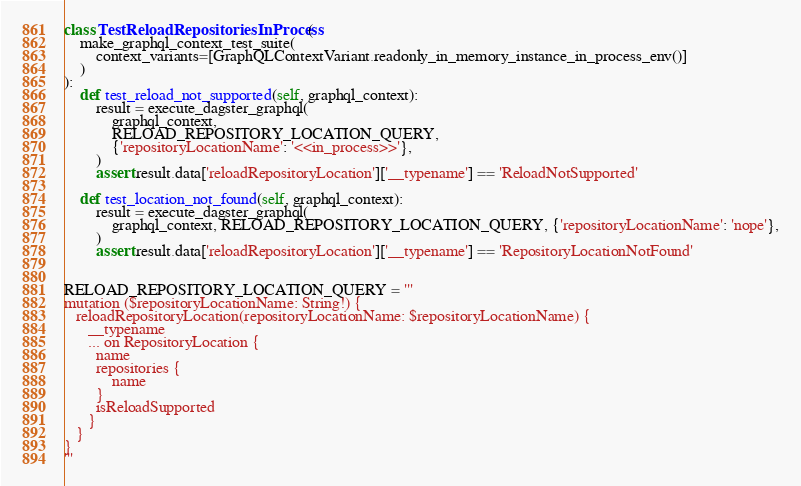Convert code to text. <code><loc_0><loc_0><loc_500><loc_500><_Python_>
class TestReloadRepositoriesInProcess(
    make_graphql_context_test_suite(
        context_variants=[GraphQLContextVariant.readonly_in_memory_instance_in_process_env()]
    )
):
    def test_reload_not_supported(self, graphql_context):
        result = execute_dagster_graphql(
            graphql_context,
            RELOAD_REPOSITORY_LOCATION_QUERY,
            {'repositoryLocationName': '<<in_process>>'},
        )
        assert result.data['reloadRepositoryLocation']['__typename'] == 'ReloadNotSupported'

    def test_location_not_found(self, graphql_context):
        result = execute_dagster_graphql(
            graphql_context, RELOAD_REPOSITORY_LOCATION_QUERY, {'repositoryLocationName': 'nope'},
        )
        assert result.data['reloadRepositoryLocation']['__typename'] == 'RepositoryLocationNotFound'


RELOAD_REPOSITORY_LOCATION_QUERY = '''
mutation ($repositoryLocationName: String!) {
   reloadRepositoryLocation(repositoryLocationName: $repositoryLocationName) {
      __typename
      ... on RepositoryLocation {
        name
        repositories {
            name
        }
        isReloadSupported
      }
   }
}
'''
</code> 